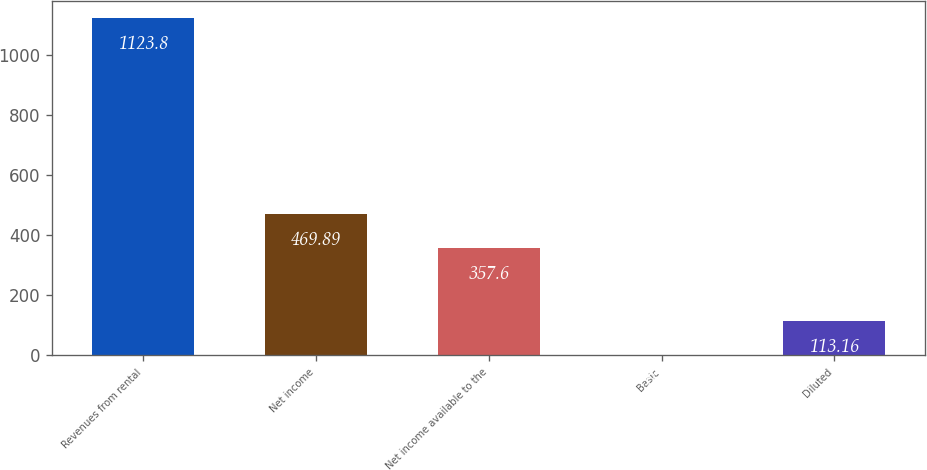Convert chart to OTSL. <chart><loc_0><loc_0><loc_500><loc_500><bar_chart><fcel>Revenues from rental<fcel>Net income<fcel>Net income available to the<fcel>Basic<fcel>Diluted<nl><fcel>1123.8<fcel>469.89<fcel>357.6<fcel>0.87<fcel>113.16<nl></chart> 